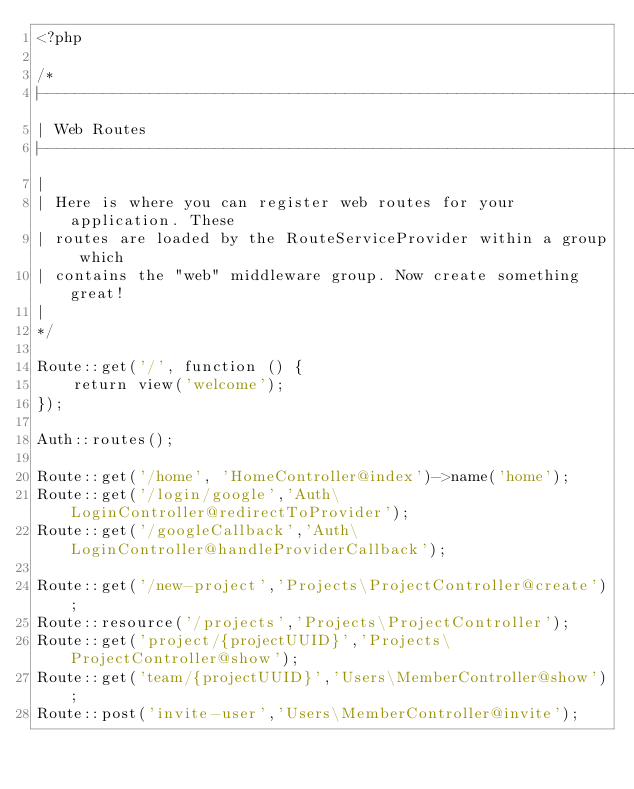<code> <loc_0><loc_0><loc_500><loc_500><_PHP_><?php

/*
|--------------------------------------------------------------------------
| Web Routes
|--------------------------------------------------------------------------
|
| Here is where you can register web routes for your application. These
| routes are loaded by the RouteServiceProvider within a group which
| contains the "web" middleware group. Now create something great!
|
*/

Route::get('/', function () {
    return view('welcome');
});

Auth::routes();

Route::get('/home', 'HomeController@index')->name('home');
Route::get('/login/google','Auth\LoginController@redirectToProvider');
Route::get('/googleCallback','Auth\LoginController@handleProviderCallback');

Route::get('/new-project','Projects\ProjectController@create');
Route::resource('/projects','Projects\ProjectController');
Route::get('project/{projectUUID}','Projects\ProjectController@show');
Route::get('team/{projectUUID}','Users\MemberController@show');
Route::post('invite-user','Users\MemberController@invite');</code> 